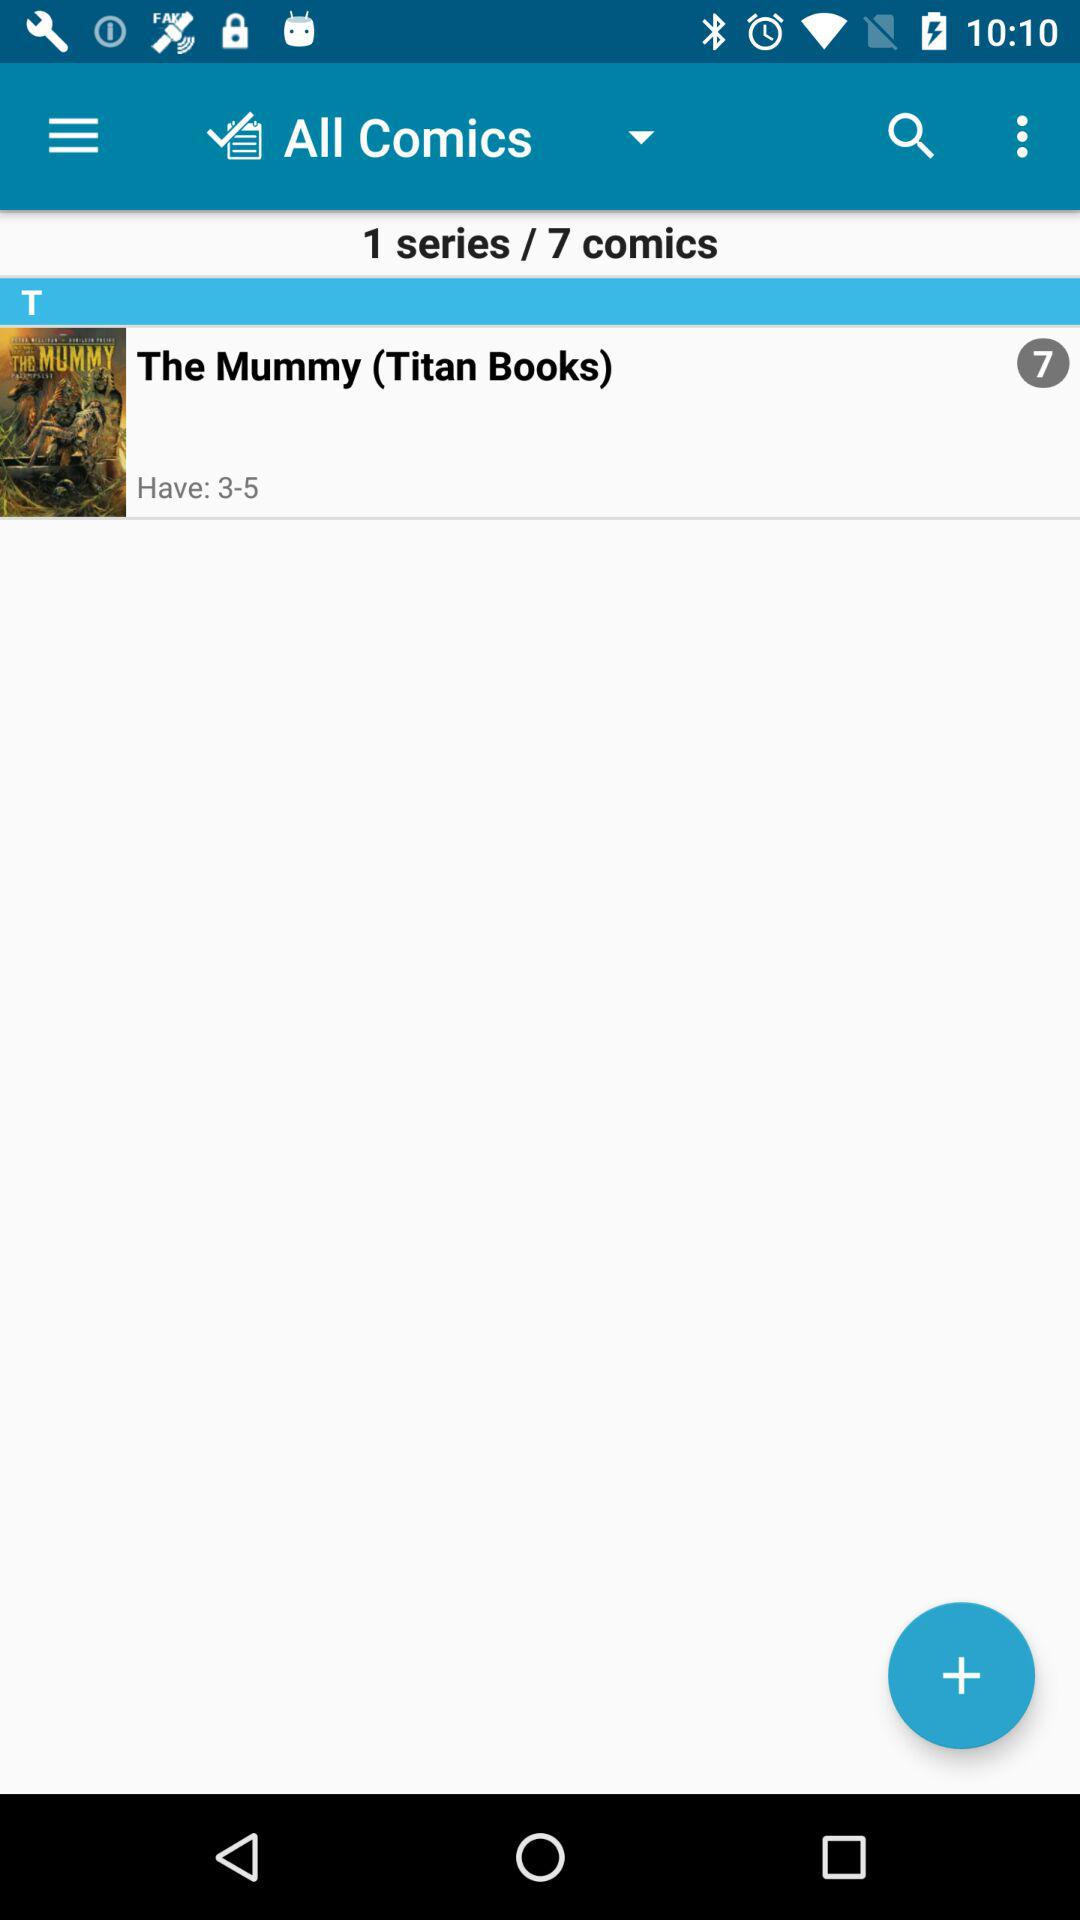What's the current number of "Have"? The current number is 3-5. 